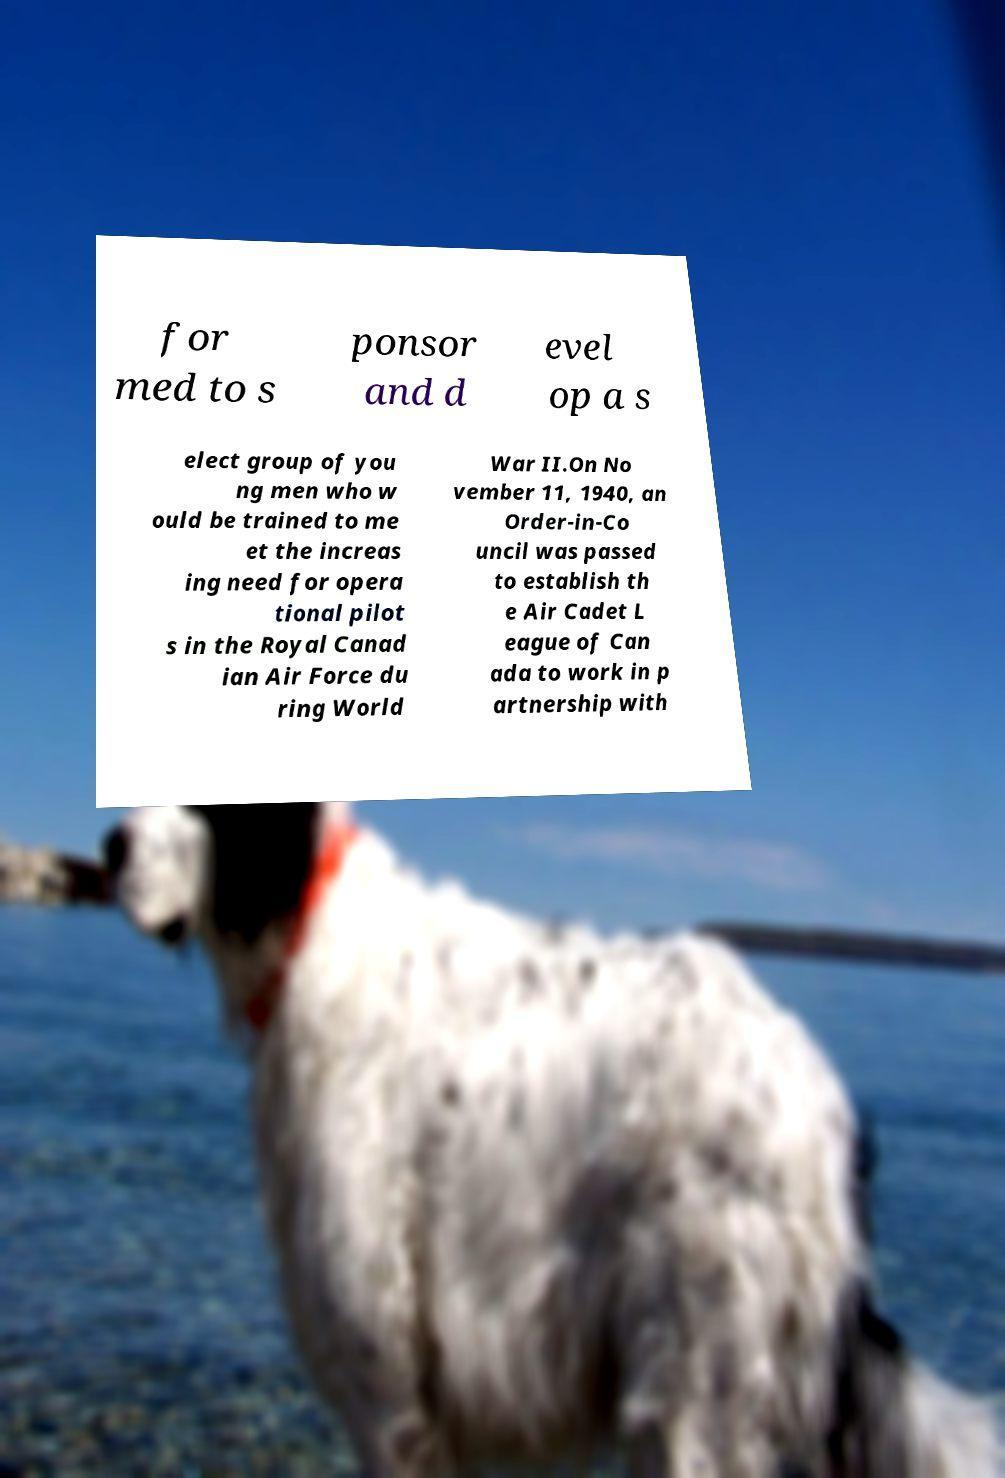Can you accurately transcribe the text from the provided image for me? for med to s ponsor and d evel op a s elect group of you ng men who w ould be trained to me et the increas ing need for opera tional pilot s in the Royal Canad ian Air Force du ring World War II.On No vember 11, 1940, an Order-in-Co uncil was passed to establish th e Air Cadet L eague of Can ada to work in p artnership with 